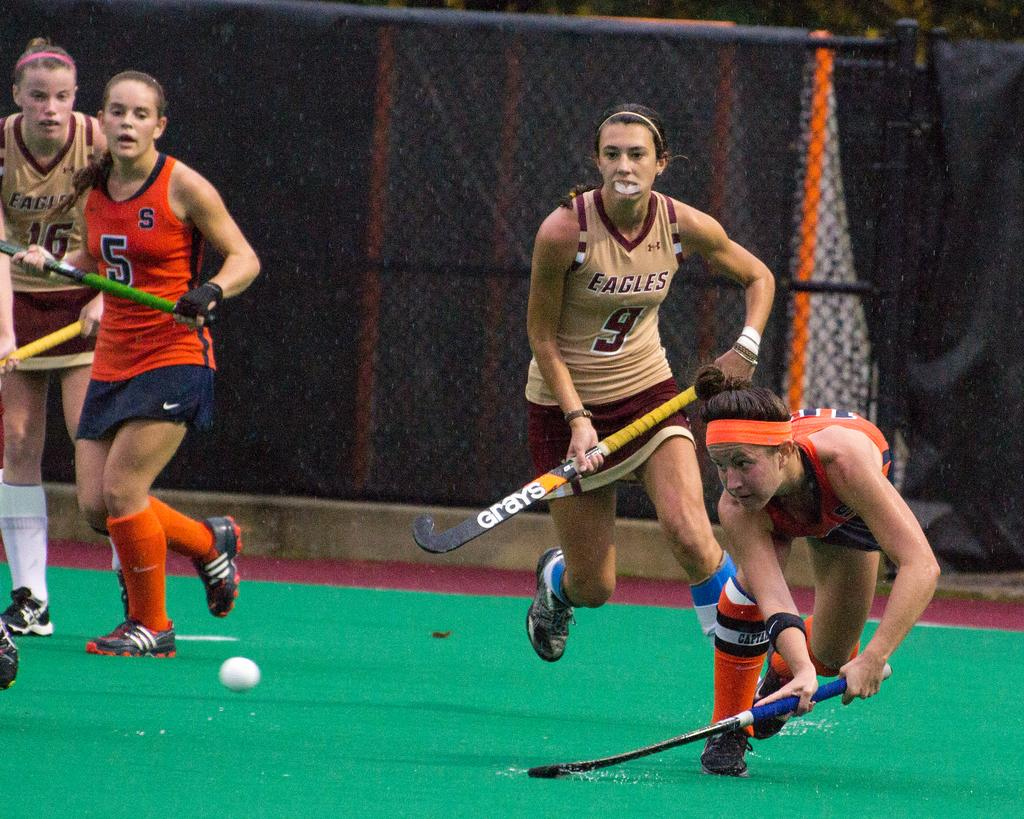<image>
Offer a succinct explanation of the picture presented. The Eagles compete against their opponents in an intense game. 